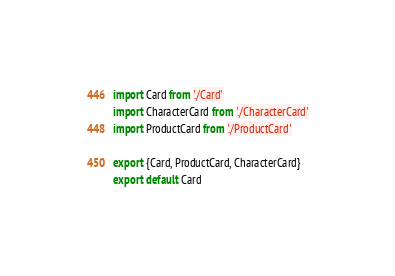Convert code to text. <code><loc_0><loc_0><loc_500><loc_500><_JavaScript_>import Card from './Card'
import CharacterCard from './CharacterCard'
import ProductCard from './ProductCard'

export {Card, ProductCard, CharacterCard}
export default Card
</code> 